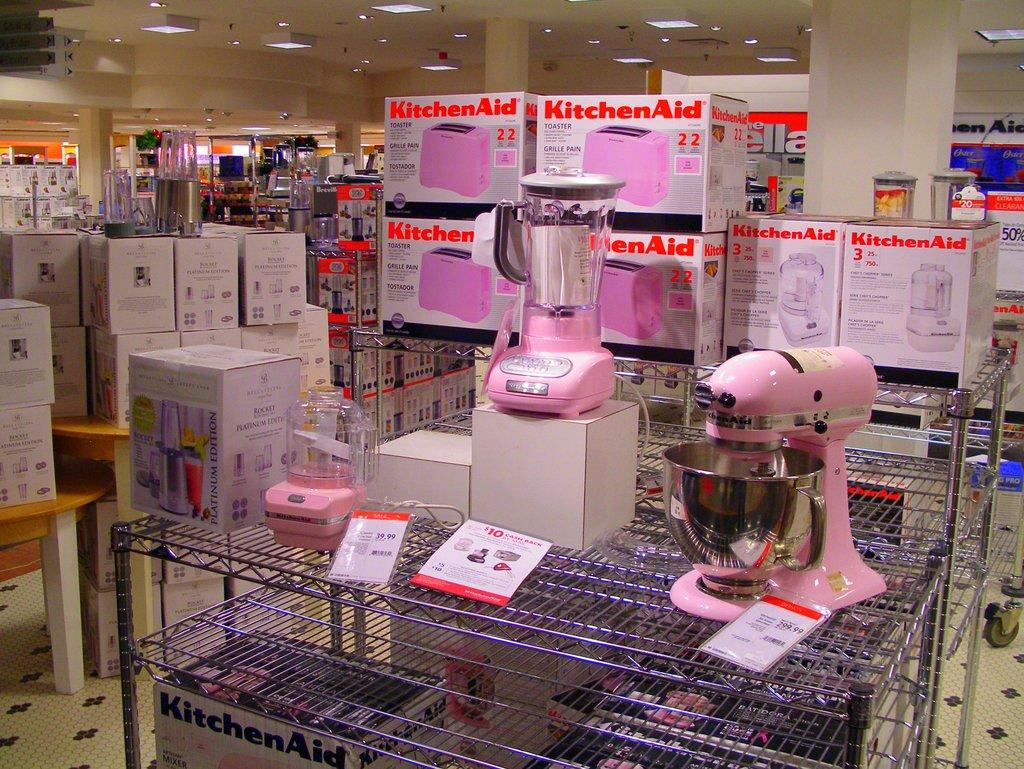<image>
Give a short and clear explanation of the subsequent image. A store display of pink KitchenAid blenders, mixers, and toasters. 